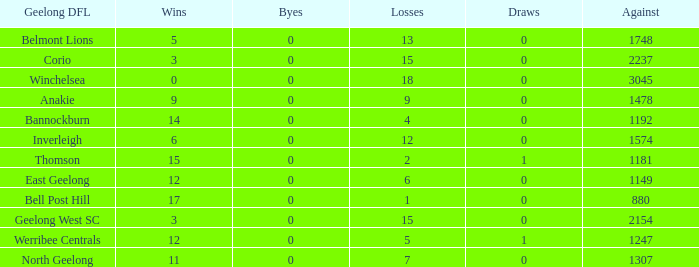What is the lowest number of wins where the byes are less than 0? None. 